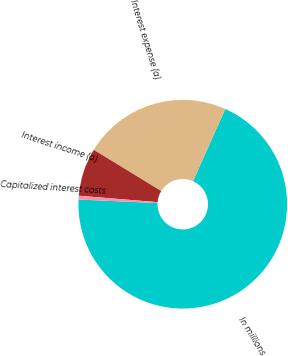Convert chart. <chart><loc_0><loc_0><loc_500><loc_500><pie_chart><fcel>In millions<fcel>Interest expense (a)<fcel>Interest income (a)<fcel>Capitalized interest costs<nl><fcel>69.04%<fcel>22.95%<fcel>7.43%<fcel>0.58%<nl></chart> 